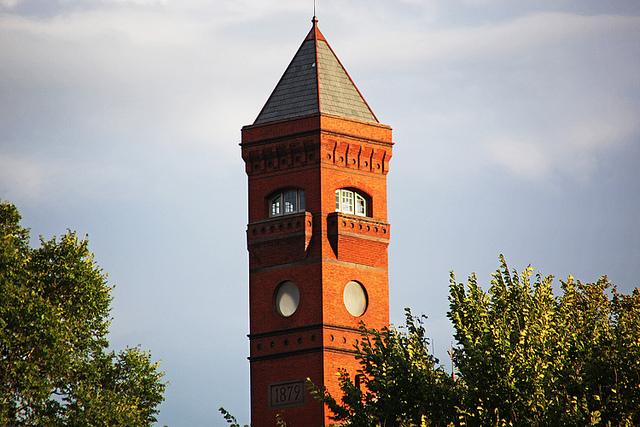Do you see a bell on top?
Short answer required. No. What is the weather like?
Give a very brief answer. Cloudy. What color is the tower?
Answer briefly. Orange. What is in the middle of this picture?
Give a very brief answer. Tower. 